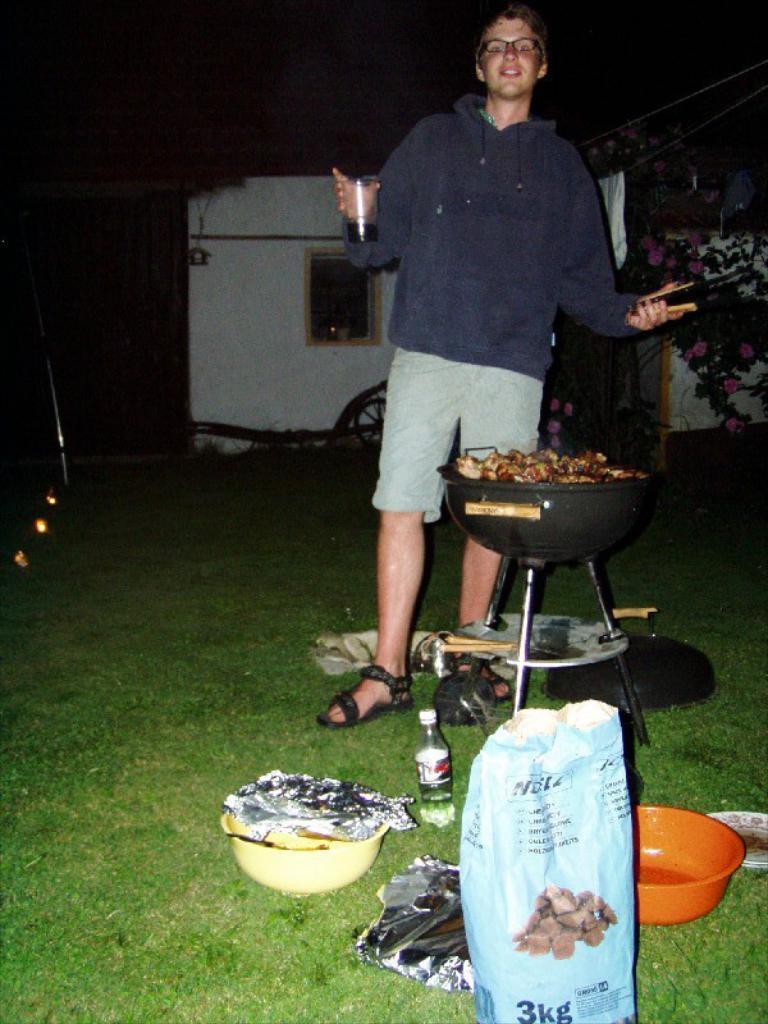How heavy is the bag?
Your answer should be compact. 3kg. 